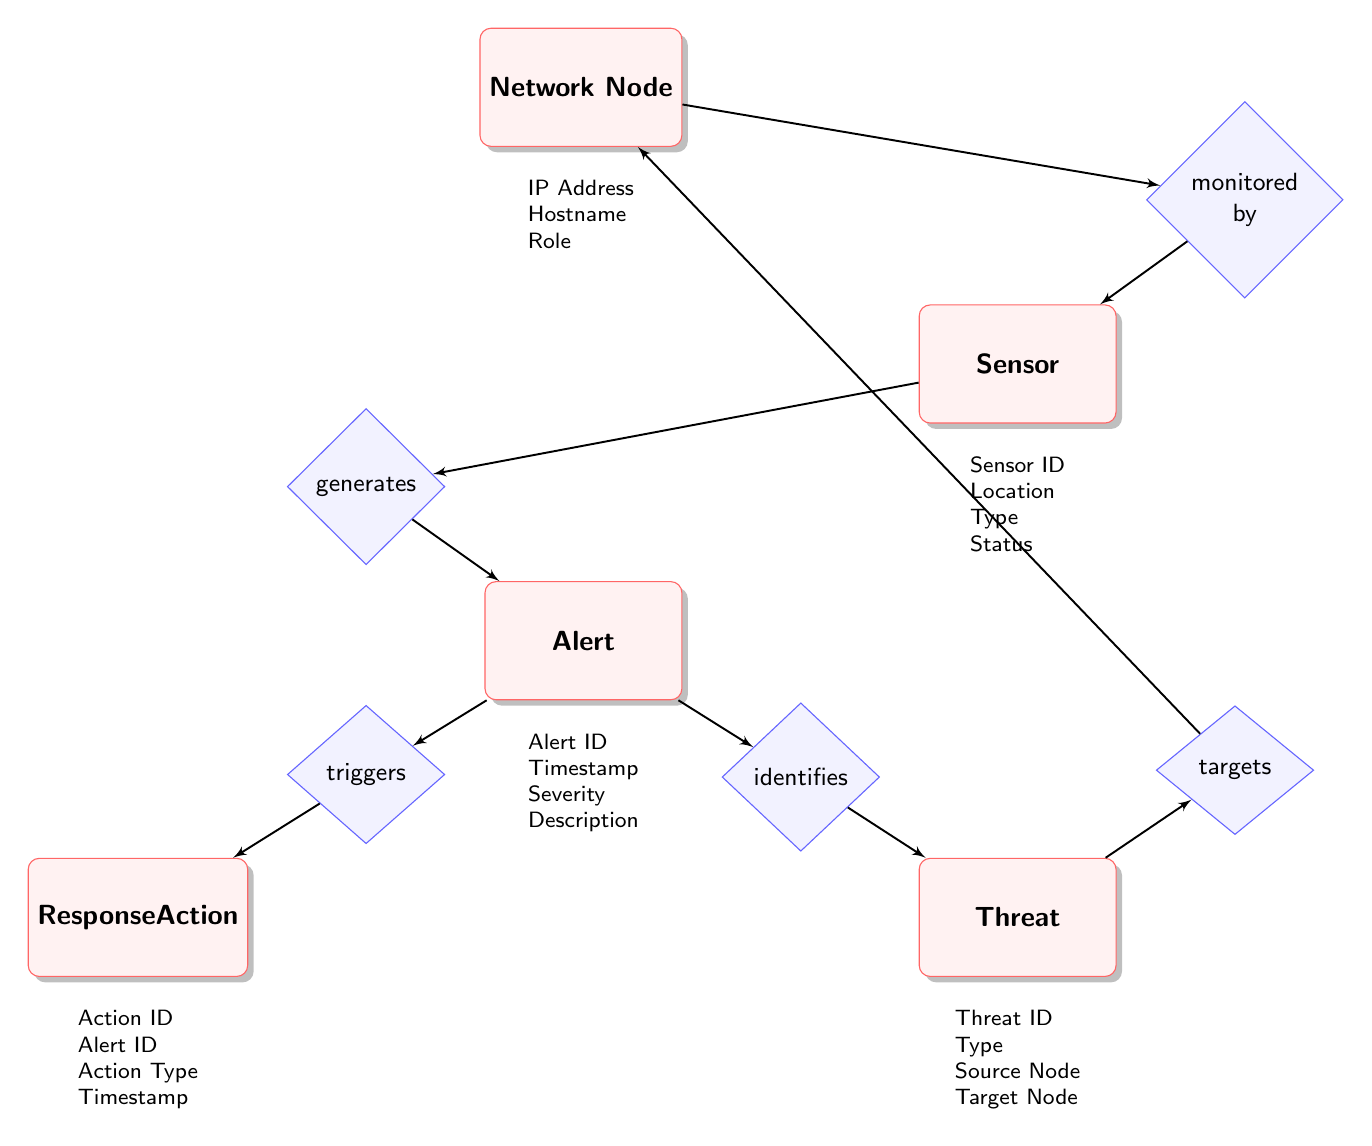What entity is monitored by the Network Node? The diagram indicates that the relationship between "Network Node" and "Sensor" is defined as "monitored by." Therefore, it is clear that "Sensor" is the entity that is monitored by "Network Node."
Answer: Sensor What relationship exists between Sensor and Alert? In the diagram, the arrow from "Sensor" to "Alert" is labeled as "generates." This shows that the "Sensor" generates an "Alert."
Answer: generates How many entities are represented in the diagram? The diagram shows five entities: "Network Node," "Sensor," "Alert," "Threat," and "Response Action." Counting these gives us a total of five entities.
Answer: 5 What is the Action Type of Response Action? The attributes listed for "Response Action" include "Action Type." This suggests that "Action Type" is a specific field of information related to the "Response Action" entity.
Answer: Action Type Which entity does the Threat identify? The relationship between "Alert" and "Threat" is labeled "identifies." Thus, the "Alert" identifies the "Threat."
Answer: Threat What are the attributes of the Alert entity? Looking at the diagram, the attributes associated with the "Alert" entity include "Alert ID," "Timestamp," "Severity," and "Description." These attributes provide various information about the "Alert."
Answer: Alert ID, Timestamp, Severity, Description What does the Response Action trigger? According to the diagram, the relationship between "Alert" and "Response Action" indicates that the "Alert" triggers a "Response Action." Hence, the response action is triggered by the alert.
Answer: Response Action Which nodes does the Threat target? The "Threat" entity has the "targets" relationship with "Network Node" as indicated in the diagram. This means that the "Threat" targets a "Network Node."
Answer: Network Node What is the relationship type between Alert and Threat? The diagram explicitly states that the connection from "Alert" to "Threat" is described by the word "identifies." This shows that "Alert" identifies "Threat."
Answer: identifies 